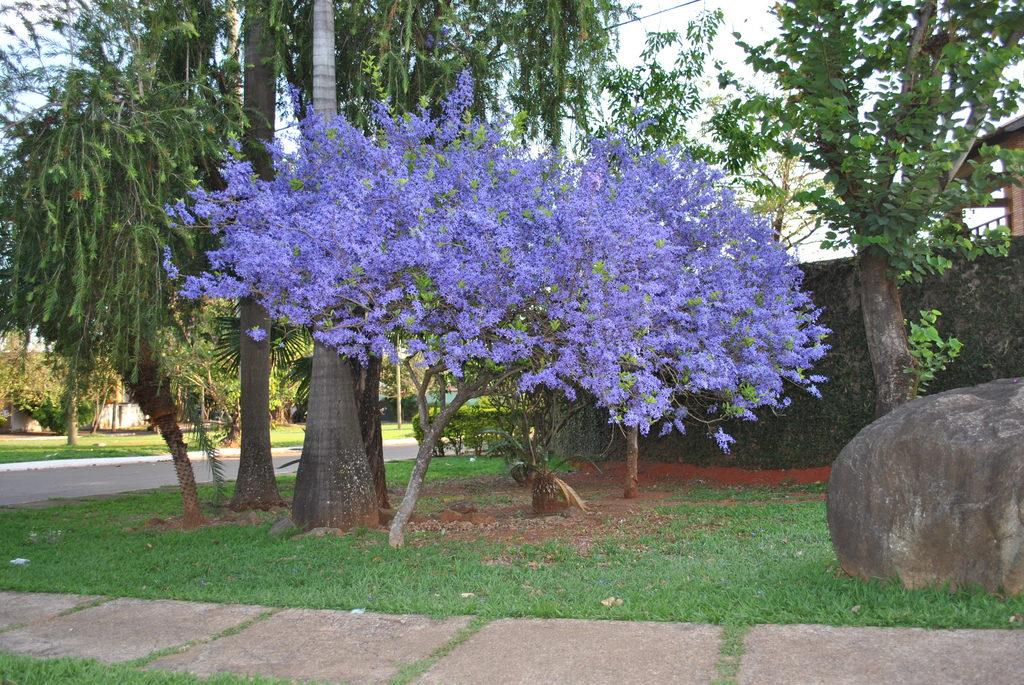What type of plants can be seen in the image? There are flowers and trees in the image. What is the ground covered with in the image? There is grass in the image. What is located on the right side of the image? There is a rock and a house on the right side of the image. Reasoning: Let'g: Let's think step by step in order to produce the conversation. We start by identifying the main subjects in the image, which are the flowers and trees. Then, we expand the conversation to include other elements such as the grass, rock, and house. Each question is designed to elicit a specific detail about the image that is known from the provided facts. Absurd Question/Answer: How does the cub interact with the flowers in the image? There is no cub present in the image, so it cannot interact with the flowers. How does the cub interact with the flowers in the image? A: There is no cub present in the image, so it cannot interact with the flowers. 